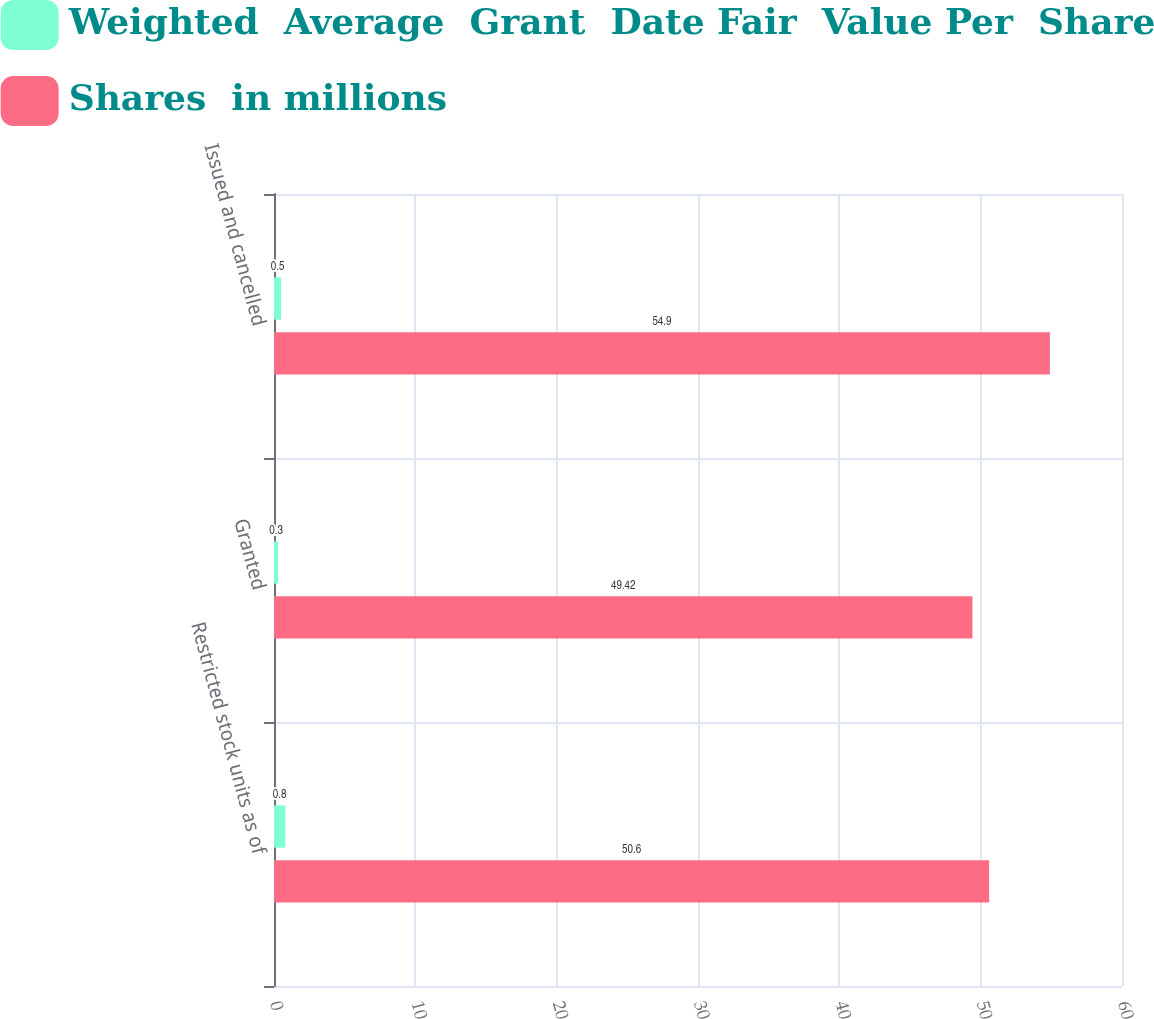<chart> <loc_0><loc_0><loc_500><loc_500><stacked_bar_chart><ecel><fcel>Restricted stock units as of<fcel>Granted<fcel>Issued and cancelled<nl><fcel>Weighted  Average  Grant  Date Fair  Value Per  Share<fcel>0.8<fcel>0.3<fcel>0.5<nl><fcel>Shares  in millions<fcel>50.6<fcel>49.42<fcel>54.9<nl></chart> 